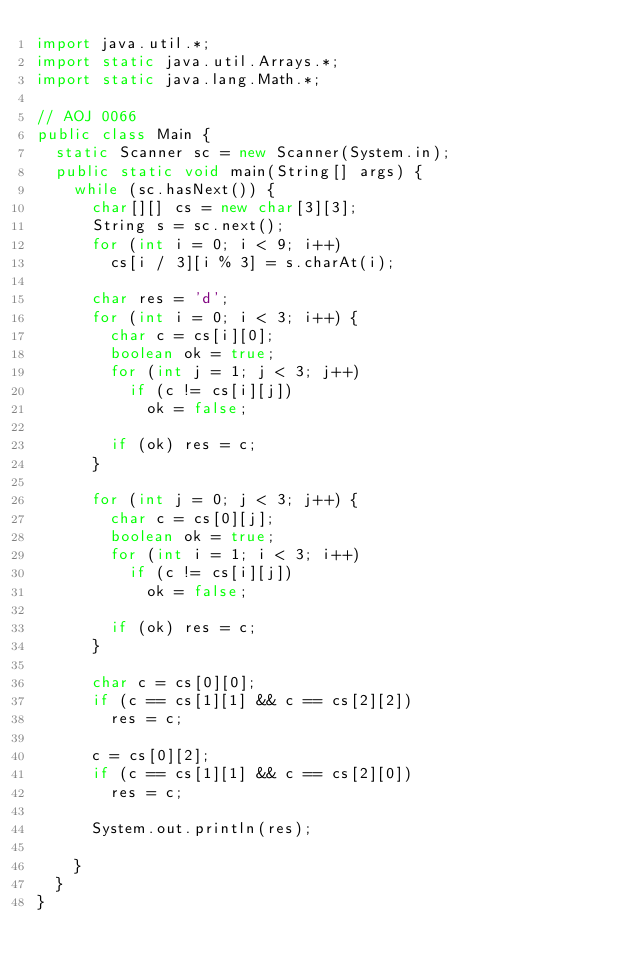<code> <loc_0><loc_0><loc_500><loc_500><_Java_>import java.util.*;
import static java.util.Arrays.*;
import static java.lang.Math.*;

// AOJ 0066
public class Main {
	static Scanner sc = new Scanner(System.in);
	public static void main(String[] args) {
		while (sc.hasNext()) {
			char[][] cs = new char[3][3];
			String s = sc.next();
			for (int i = 0; i < 9; i++)
				cs[i / 3][i % 3] = s.charAt(i);
			
			char res = 'd';
			for (int i = 0; i < 3; i++) {
				char c = cs[i][0];
				boolean ok = true;
				for (int j = 1; j < 3; j++) 
					if (c != cs[i][j])
						ok = false;
				
				if (ok) res = c;
			}
				
			for (int j = 0; j < 3; j++) {
				char c = cs[0][j];
				boolean ok = true;
				for (int i = 1; i < 3; i++) 
					if (c != cs[i][j])
						ok = false;
				
				if (ok) res = c;
			}
			
			char c = cs[0][0];
			if (c == cs[1][1] && c == cs[2][2])
				res = c;

			c = cs[0][2];
			if (c == cs[1][1] && c == cs[2][0])
				res = c;

			System.out.println(res);
			
		}
	}
}</code> 